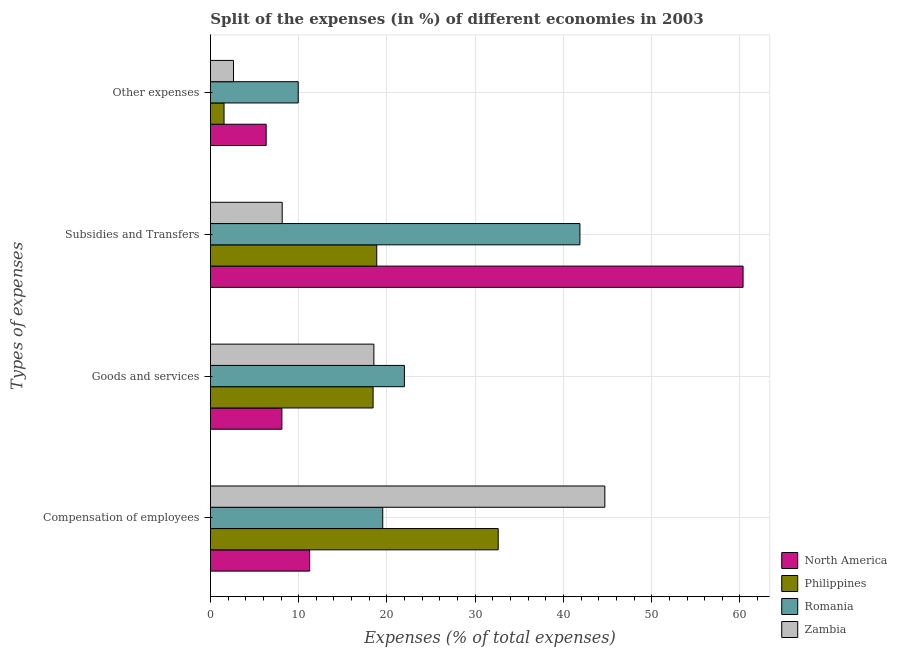Are the number of bars per tick equal to the number of legend labels?
Keep it short and to the point. Yes. What is the label of the 2nd group of bars from the top?
Your answer should be very brief. Subsidies and Transfers. What is the percentage of amount spent on subsidies in Zambia?
Your answer should be very brief. 8.14. Across all countries, what is the maximum percentage of amount spent on compensation of employees?
Provide a succinct answer. 44.69. Across all countries, what is the minimum percentage of amount spent on goods and services?
Offer a terse response. 8.1. In which country was the percentage of amount spent on goods and services maximum?
Ensure brevity in your answer.  Romania. What is the total percentage of amount spent on other expenses in the graph?
Give a very brief answer. 20.44. What is the difference between the percentage of amount spent on goods and services in Romania and that in North America?
Ensure brevity in your answer.  13.88. What is the difference between the percentage of amount spent on compensation of employees in Zambia and the percentage of amount spent on goods and services in Romania?
Offer a terse response. 22.71. What is the average percentage of amount spent on subsidies per country?
Offer a terse response. 32.3. What is the difference between the percentage of amount spent on subsidies and percentage of amount spent on other expenses in North America?
Your answer should be compact. 54.03. In how many countries, is the percentage of amount spent on goods and services greater than 58 %?
Offer a very short reply. 0. What is the ratio of the percentage of amount spent on compensation of employees in Zambia to that in Philippines?
Provide a short and direct response. 1.37. What is the difference between the highest and the second highest percentage of amount spent on other expenses?
Ensure brevity in your answer.  3.63. What is the difference between the highest and the lowest percentage of amount spent on compensation of employees?
Offer a very short reply. 33.44. In how many countries, is the percentage of amount spent on compensation of employees greater than the average percentage of amount spent on compensation of employees taken over all countries?
Your response must be concise. 2. Is the sum of the percentage of amount spent on goods and services in Philippines and Romania greater than the maximum percentage of amount spent on compensation of employees across all countries?
Provide a succinct answer. No. Is it the case that in every country, the sum of the percentage of amount spent on compensation of employees and percentage of amount spent on goods and services is greater than the sum of percentage of amount spent on subsidies and percentage of amount spent on other expenses?
Provide a succinct answer. No. What does the 3rd bar from the bottom in Other expenses represents?
Make the answer very short. Romania. Is it the case that in every country, the sum of the percentage of amount spent on compensation of employees and percentage of amount spent on goods and services is greater than the percentage of amount spent on subsidies?
Offer a terse response. No. Are all the bars in the graph horizontal?
Give a very brief answer. Yes. How many countries are there in the graph?
Offer a terse response. 4. What is the difference between two consecutive major ticks on the X-axis?
Provide a succinct answer. 10. Are the values on the major ticks of X-axis written in scientific E-notation?
Provide a short and direct response. No. Where does the legend appear in the graph?
Offer a very short reply. Bottom right. How many legend labels are there?
Your answer should be compact. 4. How are the legend labels stacked?
Ensure brevity in your answer.  Vertical. What is the title of the graph?
Offer a terse response. Split of the expenses (in %) of different economies in 2003. Does "Greece" appear as one of the legend labels in the graph?
Your answer should be compact. No. What is the label or title of the X-axis?
Provide a succinct answer. Expenses (% of total expenses). What is the label or title of the Y-axis?
Ensure brevity in your answer.  Types of expenses. What is the Expenses (% of total expenses) of North America in Compensation of employees?
Make the answer very short. 11.25. What is the Expenses (% of total expenses) of Philippines in Compensation of employees?
Your answer should be very brief. 32.61. What is the Expenses (% of total expenses) of Romania in Compensation of employees?
Your answer should be very brief. 19.53. What is the Expenses (% of total expenses) of Zambia in Compensation of employees?
Keep it short and to the point. 44.69. What is the Expenses (% of total expenses) in North America in Goods and services?
Ensure brevity in your answer.  8.1. What is the Expenses (% of total expenses) of Philippines in Goods and services?
Your response must be concise. 18.44. What is the Expenses (% of total expenses) of Romania in Goods and services?
Ensure brevity in your answer.  21.98. What is the Expenses (% of total expenses) of Zambia in Goods and services?
Offer a terse response. 18.52. What is the Expenses (% of total expenses) of North America in Subsidies and Transfers?
Your answer should be very brief. 60.35. What is the Expenses (% of total expenses) of Philippines in Subsidies and Transfers?
Your answer should be compact. 18.85. What is the Expenses (% of total expenses) in Romania in Subsidies and Transfers?
Provide a succinct answer. 41.87. What is the Expenses (% of total expenses) in Zambia in Subsidies and Transfers?
Provide a succinct answer. 8.14. What is the Expenses (% of total expenses) of North America in Other expenses?
Offer a terse response. 6.32. What is the Expenses (% of total expenses) in Philippines in Other expenses?
Keep it short and to the point. 1.55. What is the Expenses (% of total expenses) in Romania in Other expenses?
Offer a terse response. 9.95. What is the Expenses (% of total expenses) in Zambia in Other expenses?
Your answer should be compact. 2.62. Across all Types of expenses, what is the maximum Expenses (% of total expenses) of North America?
Your answer should be very brief. 60.35. Across all Types of expenses, what is the maximum Expenses (% of total expenses) of Philippines?
Your answer should be compact. 32.61. Across all Types of expenses, what is the maximum Expenses (% of total expenses) in Romania?
Offer a very short reply. 41.87. Across all Types of expenses, what is the maximum Expenses (% of total expenses) of Zambia?
Provide a succinct answer. 44.69. Across all Types of expenses, what is the minimum Expenses (% of total expenses) in North America?
Your answer should be very brief. 6.32. Across all Types of expenses, what is the minimum Expenses (% of total expenses) of Philippines?
Your response must be concise. 1.55. Across all Types of expenses, what is the minimum Expenses (% of total expenses) of Romania?
Your answer should be very brief. 9.95. Across all Types of expenses, what is the minimum Expenses (% of total expenses) in Zambia?
Offer a very short reply. 2.62. What is the total Expenses (% of total expenses) of North America in the graph?
Your response must be concise. 86.02. What is the total Expenses (% of total expenses) of Philippines in the graph?
Provide a succinct answer. 71.44. What is the total Expenses (% of total expenses) in Romania in the graph?
Your answer should be compact. 93.33. What is the total Expenses (% of total expenses) of Zambia in the graph?
Offer a terse response. 73.97. What is the difference between the Expenses (% of total expenses) of North America in Compensation of employees and that in Goods and services?
Offer a terse response. 3.15. What is the difference between the Expenses (% of total expenses) in Philippines in Compensation of employees and that in Goods and services?
Keep it short and to the point. 14.17. What is the difference between the Expenses (% of total expenses) in Romania in Compensation of employees and that in Goods and services?
Provide a succinct answer. -2.46. What is the difference between the Expenses (% of total expenses) of Zambia in Compensation of employees and that in Goods and services?
Offer a terse response. 26.17. What is the difference between the Expenses (% of total expenses) in North America in Compensation of employees and that in Subsidies and Transfers?
Provide a succinct answer. -49.11. What is the difference between the Expenses (% of total expenses) in Philippines in Compensation of employees and that in Subsidies and Transfers?
Offer a very short reply. 13.76. What is the difference between the Expenses (% of total expenses) of Romania in Compensation of employees and that in Subsidies and Transfers?
Your answer should be compact. -22.34. What is the difference between the Expenses (% of total expenses) in Zambia in Compensation of employees and that in Subsidies and Transfers?
Keep it short and to the point. 36.55. What is the difference between the Expenses (% of total expenses) in North America in Compensation of employees and that in Other expenses?
Provide a short and direct response. 4.93. What is the difference between the Expenses (% of total expenses) in Philippines in Compensation of employees and that in Other expenses?
Offer a terse response. 31.06. What is the difference between the Expenses (% of total expenses) in Romania in Compensation of employees and that in Other expenses?
Your answer should be compact. 9.57. What is the difference between the Expenses (% of total expenses) in Zambia in Compensation of employees and that in Other expenses?
Offer a very short reply. 42.07. What is the difference between the Expenses (% of total expenses) in North America in Goods and services and that in Subsidies and Transfers?
Offer a very short reply. -52.25. What is the difference between the Expenses (% of total expenses) of Philippines in Goods and services and that in Subsidies and Transfers?
Give a very brief answer. -0.41. What is the difference between the Expenses (% of total expenses) in Romania in Goods and services and that in Subsidies and Transfers?
Keep it short and to the point. -19.88. What is the difference between the Expenses (% of total expenses) of Zambia in Goods and services and that in Subsidies and Transfers?
Provide a short and direct response. 10.39. What is the difference between the Expenses (% of total expenses) in North America in Goods and services and that in Other expenses?
Give a very brief answer. 1.78. What is the difference between the Expenses (% of total expenses) of Philippines in Goods and services and that in Other expenses?
Your answer should be very brief. 16.89. What is the difference between the Expenses (% of total expenses) in Romania in Goods and services and that in Other expenses?
Provide a short and direct response. 12.03. What is the difference between the Expenses (% of total expenses) of Zambia in Goods and services and that in Other expenses?
Keep it short and to the point. 15.9. What is the difference between the Expenses (% of total expenses) in North America in Subsidies and Transfers and that in Other expenses?
Provide a short and direct response. 54.03. What is the difference between the Expenses (% of total expenses) of Philippines in Subsidies and Transfers and that in Other expenses?
Your response must be concise. 17.3. What is the difference between the Expenses (% of total expenses) in Romania in Subsidies and Transfers and that in Other expenses?
Provide a succinct answer. 31.91. What is the difference between the Expenses (% of total expenses) in Zambia in Subsidies and Transfers and that in Other expenses?
Provide a short and direct response. 5.52. What is the difference between the Expenses (% of total expenses) in North America in Compensation of employees and the Expenses (% of total expenses) in Philippines in Goods and services?
Provide a succinct answer. -7.19. What is the difference between the Expenses (% of total expenses) in North America in Compensation of employees and the Expenses (% of total expenses) in Romania in Goods and services?
Your response must be concise. -10.74. What is the difference between the Expenses (% of total expenses) in North America in Compensation of employees and the Expenses (% of total expenses) in Zambia in Goods and services?
Provide a succinct answer. -7.28. What is the difference between the Expenses (% of total expenses) in Philippines in Compensation of employees and the Expenses (% of total expenses) in Romania in Goods and services?
Give a very brief answer. 10.63. What is the difference between the Expenses (% of total expenses) of Philippines in Compensation of employees and the Expenses (% of total expenses) of Zambia in Goods and services?
Your response must be concise. 14.08. What is the difference between the Expenses (% of total expenses) of North America in Compensation of employees and the Expenses (% of total expenses) of Philippines in Subsidies and Transfers?
Your answer should be very brief. -7.6. What is the difference between the Expenses (% of total expenses) in North America in Compensation of employees and the Expenses (% of total expenses) in Romania in Subsidies and Transfers?
Offer a very short reply. -30.62. What is the difference between the Expenses (% of total expenses) in North America in Compensation of employees and the Expenses (% of total expenses) in Zambia in Subsidies and Transfers?
Offer a terse response. 3.11. What is the difference between the Expenses (% of total expenses) of Philippines in Compensation of employees and the Expenses (% of total expenses) of Romania in Subsidies and Transfers?
Offer a very short reply. -9.26. What is the difference between the Expenses (% of total expenses) of Philippines in Compensation of employees and the Expenses (% of total expenses) of Zambia in Subsidies and Transfers?
Your response must be concise. 24.47. What is the difference between the Expenses (% of total expenses) in Romania in Compensation of employees and the Expenses (% of total expenses) in Zambia in Subsidies and Transfers?
Provide a short and direct response. 11.39. What is the difference between the Expenses (% of total expenses) in North America in Compensation of employees and the Expenses (% of total expenses) in Philippines in Other expenses?
Ensure brevity in your answer.  9.7. What is the difference between the Expenses (% of total expenses) in North America in Compensation of employees and the Expenses (% of total expenses) in Romania in Other expenses?
Provide a succinct answer. 1.29. What is the difference between the Expenses (% of total expenses) of North America in Compensation of employees and the Expenses (% of total expenses) of Zambia in Other expenses?
Make the answer very short. 8.63. What is the difference between the Expenses (% of total expenses) of Philippines in Compensation of employees and the Expenses (% of total expenses) of Romania in Other expenses?
Your answer should be compact. 22.66. What is the difference between the Expenses (% of total expenses) of Philippines in Compensation of employees and the Expenses (% of total expenses) of Zambia in Other expenses?
Keep it short and to the point. 29.99. What is the difference between the Expenses (% of total expenses) of Romania in Compensation of employees and the Expenses (% of total expenses) of Zambia in Other expenses?
Offer a very short reply. 16.91. What is the difference between the Expenses (% of total expenses) in North America in Goods and services and the Expenses (% of total expenses) in Philippines in Subsidies and Transfers?
Provide a succinct answer. -10.75. What is the difference between the Expenses (% of total expenses) in North America in Goods and services and the Expenses (% of total expenses) in Romania in Subsidies and Transfers?
Provide a short and direct response. -33.77. What is the difference between the Expenses (% of total expenses) of North America in Goods and services and the Expenses (% of total expenses) of Zambia in Subsidies and Transfers?
Provide a short and direct response. -0.04. What is the difference between the Expenses (% of total expenses) in Philippines in Goods and services and the Expenses (% of total expenses) in Romania in Subsidies and Transfers?
Your answer should be very brief. -23.43. What is the difference between the Expenses (% of total expenses) in Philippines in Goods and services and the Expenses (% of total expenses) in Zambia in Subsidies and Transfers?
Offer a terse response. 10.3. What is the difference between the Expenses (% of total expenses) of Romania in Goods and services and the Expenses (% of total expenses) of Zambia in Subsidies and Transfers?
Offer a terse response. 13.85. What is the difference between the Expenses (% of total expenses) in North America in Goods and services and the Expenses (% of total expenses) in Philippines in Other expenses?
Provide a succinct answer. 6.55. What is the difference between the Expenses (% of total expenses) in North America in Goods and services and the Expenses (% of total expenses) in Romania in Other expenses?
Keep it short and to the point. -1.85. What is the difference between the Expenses (% of total expenses) in North America in Goods and services and the Expenses (% of total expenses) in Zambia in Other expenses?
Keep it short and to the point. 5.48. What is the difference between the Expenses (% of total expenses) in Philippines in Goods and services and the Expenses (% of total expenses) in Romania in Other expenses?
Keep it short and to the point. 8.48. What is the difference between the Expenses (% of total expenses) in Philippines in Goods and services and the Expenses (% of total expenses) in Zambia in Other expenses?
Give a very brief answer. 15.81. What is the difference between the Expenses (% of total expenses) in Romania in Goods and services and the Expenses (% of total expenses) in Zambia in Other expenses?
Give a very brief answer. 19.36. What is the difference between the Expenses (% of total expenses) in North America in Subsidies and Transfers and the Expenses (% of total expenses) in Philippines in Other expenses?
Offer a terse response. 58.8. What is the difference between the Expenses (% of total expenses) in North America in Subsidies and Transfers and the Expenses (% of total expenses) in Romania in Other expenses?
Provide a short and direct response. 50.4. What is the difference between the Expenses (% of total expenses) of North America in Subsidies and Transfers and the Expenses (% of total expenses) of Zambia in Other expenses?
Make the answer very short. 57.73. What is the difference between the Expenses (% of total expenses) in Philippines in Subsidies and Transfers and the Expenses (% of total expenses) in Romania in Other expenses?
Offer a terse response. 8.89. What is the difference between the Expenses (% of total expenses) of Philippines in Subsidies and Transfers and the Expenses (% of total expenses) of Zambia in Other expenses?
Provide a succinct answer. 16.23. What is the difference between the Expenses (% of total expenses) in Romania in Subsidies and Transfers and the Expenses (% of total expenses) in Zambia in Other expenses?
Make the answer very short. 39.25. What is the average Expenses (% of total expenses) in North America per Types of expenses?
Provide a succinct answer. 21.5. What is the average Expenses (% of total expenses) of Philippines per Types of expenses?
Offer a terse response. 17.86. What is the average Expenses (% of total expenses) in Romania per Types of expenses?
Give a very brief answer. 23.33. What is the average Expenses (% of total expenses) in Zambia per Types of expenses?
Give a very brief answer. 18.49. What is the difference between the Expenses (% of total expenses) of North America and Expenses (% of total expenses) of Philippines in Compensation of employees?
Offer a terse response. -21.36. What is the difference between the Expenses (% of total expenses) in North America and Expenses (% of total expenses) in Romania in Compensation of employees?
Provide a succinct answer. -8.28. What is the difference between the Expenses (% of total expenses) in North America and Expenses (% of total expenses) in Zambia in Compensation of employees?
Your answer should be very brief. -33.44. What is the difference between the Expenses (% of total expenses) of Philippines and Expenses (% of total expenses) of Romania in Compensation of employees?
Provide a short and direct response. 13.08. What is the difference between the Expenses (% of total expenses) in Philippines and Expenses (% of total expenses) in Zambia in Compensation of employees?
Provide a succinct answer. -12.08. What is the difference between the Expenses (% of total expenses) of Romania and Expenses (% of total expenses) of Zambia in Compensation of employees?
Make the answer very short. -25.16. What is the difference between the Expenses (% of total expenses) in North America and Expenses (% of total expenses) in Philippines in Goods and services?
Give a very brief answer. -10.33. What is the difference between the Expenses (% of total expenses) of North America and Expenses (% of total expenses) of Romania in Goods and services?
Your answer should be compact. -13.88. What is the difference between the Expenses (% of total expenses) in North America and Expenses (% of total expenses) in Zambia in Goods and services?
Your answer should be compact. -10.42. What is the difference between the Expenses (% of total expenses) of Philippines and Expenses (% of total expenses) of Romania in Goods and services?
Offer a terse response. -3.55. What is the difference between the Expenses (% of total expenses) of Philippines and Expenses (% of total expenses) of Zambia in Goods and services?
Your response must be concise. -0.09. What is the difference between the Expenses (% of total expenses) in Romania and Expenses (% of total expenses) in Zambia in Goods and services?
Your answer should be compact. 3.46. What is the difference between the Expenses (% of total expenses) of North America and Expenses (% of total expenses) of Philippines in Subsidies and Transfers?
Make the answer very short. 41.5. What is the difference between the Expenses (% of total expenses) in North America and Expenses (% of total expenses) in Romania in Subsidies and Transfers?
Give a very brief answer. 18.49. What is the difference between the Expenses (% of total expenses) in North America and Expenses (% of total expenses) in Zambia in Subsidies and Transfers?
Your response must be concise. 52.22. What is the difference between the Expenses (% of total expenses) of Philippines and Expenses (% of total expenses) of Romania in Subsidies and Transfers?
Offer a very short reply. -23.02. What is the difference between the Expenses (% of total expenses) in Philippines and Expenses (% of total expenses) in Zambia in Subsidies and Transfers?
Make the answer very short. 10.71. What is the difference between the Expenses (% of total expenses) in Romania and Expenses (% of total expenses) in Zambia in Subsidies and Transfers?
Make the answer very short. 33.73. What is the difference between the Expenses (% of total expenses) of North America and Expenses (% of total expenses) of Philippines in Other expenses?
Offer a terse response. 4.77. What is the difference between the Expenses (% of total expenses) in North America and Expenses (% of total expenses) in Romania in Other expenses?
Keep it short and to the point. -3.63. What is the difference between the Expenses (% of total expenses) in North America and Expenses (% of total expenses) in Zambia in Other expenses?
Your answer should be compact. 3.7. What is the difference between the Expenses (% of total expenses) in Philippines and Expenses (% of total expenses) in Romania in Other expenses?
Provide a short and direct response. -8.41. What is the difference between the Expenses (% of total expenses) in Philippines and Expenses (% of total expenses) in Zambia in Other expenses?
Give a very brief answer. -1.07. What is the difference between the Expenses (% of total expenses) in Romania and Expenses (% of total expenses) in Zambia in Other expenses?
Offer a terse response. 7.33. What is the ratio of the Expenses (% of total expenses) of North America in Compensation of employees to that in Goods and services?
Ensure brevity in your answer.  1.39. What is the ratio of the Expenses (% of total expenses) in Philippines in Compensation of employees to that in Goods and services?
Give a very brief answer. 1.77. What is the ratio of the Expenses (% of total expenses) of Romania in Compensation of employees to that in Goods and services?
Provide a succinct answer. 0.89. What is the ratio of the Expenses (% of total expenses) in Zambia in Compensation of employees to that in Goods and services?
Your answer should be very brief. 2.41. What is the ratio of the Expenses (% of total expenses) in North America in Compensation of employees to that in Subsidies and Transfers?
Your answer should be compact. 0.19. What is the ratio of the Expenses (% of total expenses) in Philippines in Compensation of employees to that in Subsidies and Transfers?
Make the answer very short. 1.73. What is the ratio of the Expenses (% of total expenses) in Romania in Compensation of employees to that in Subsidies and Transfers?
Provide a short and direct response. 0.47. What is the ratio of the Expenses (% of total expenses) in Zambia in Compensation of employees to that in Subsidies and Transfers?
Provide a short and direct response. 5.49. What is the ratio of the Expenses (% of total expenses) in North America in Compensation of employees to that in Other expenses?
Your answer should be compact. 1.78. What is the ratio of the Expenses (% of total expenses) of Philippines in Compensation of employees to that in Other expenses?
Provide a short and direct response. 21.06. What is the ratio of the Expenses (% of total expenses) of Romania in Compensation of employees to that in Other expenses?
Offer a terse response. 1.96. What is the ratio of the Expenses (% of total expenses) of Zambia in Compensation of employees to that in Other expenses?
Offer a terse response. 17.05. What is the ratio of the Expenses (% of total expenses) in North America in Goods and services to that in Subsidies and Transfers?
Provide a succinct answer. 0.13. What is the ratio of the Expenses (% of total expenses) in Philippines in Goods and services to that in Subsidies and Transfers?
Keep it short and to the point. 0.98. What is the ratio of the Expenses (% of total expenses) in Romania in Goods and services to that in Subsidies and Transfers?
Provide a short and direct response. 0.53. What is the ratio of the Expenses (% of total expenses) of Zambia in Goods and services to that in Subsidies and Transfers?
Keep it short and to the point. 2.28. What is the ratio of the Expenses (% of total expenses) in North America in Goods and services to that in Other expenses?
Give a very brief answer. 1.28. What is the ratio of the Expenses (% of total expenses) in Philippines in Goods and services to that in Other expenses?
Give a very brief answer. 11.91. What is the ratio of the Expenses (% of total expenses) of Romania in Goods and services to that in Other expenses?
Make the answer very short. 2.21. What is the ratio of the Expenses (% of total expenses) in Zambia in Goods and services to that in Other expenses?
Offer a very short reply. 7.07. What is the ratio of the Expenses (% of total expenses) in North America in Subsidies and Transfers to that in Other expenses?
Provide a short and direct response. 9.55. What is the ratio of the Expenses (% of total expenses) in Philippines in Subsidies and Transfers to that in Other expenses?
Ensure brevity in your answer.  12.17. What is the ratio of the Expenses (% of total expenses) in Romania in Subsidies and Transfers to that in Other expenses?
Give a very brief answer. 4.21. What is the ratio of the Expenses (% of total expenses) in Zambia in Subsidies and Transfers to that in Other expenses?
Keep it short and to the point. 3.1. What is the difference between the highest and the second highest Expenses (% of total expenses) of North America?
Your answer should be compact. 49.11. What is the difference between the highest and the second highest Expenses (% of total expenses) of Philippines?
Your answer should be very brief. 13.76. What is the difference between the highest and the second highest Expenses (% of total expenses) in Romania?
Offer a terse response. 19.88. What is the difference between the highest and the second highest Expenses (% of total expenses) in Zambia?
Your answer should be compact. 26.17. What is the difference between the highest and the lowest Expenses (% of total expenses) in North America?
Provide a short and direct response. 54.03. What is the difference between the highest and the lowest Expenses (% of total expenses) in Philippines?
Ensure brevity in your answer.  31.06. What is the difference between the highest and the lowest Expenses (% of total expenses) in Romania?
Your answer should be compact. 31.91. What is the difference between the highest and the lowest Expenses (% of total expenses) in Zambia?
Keep it short and to the point. 42.07. 